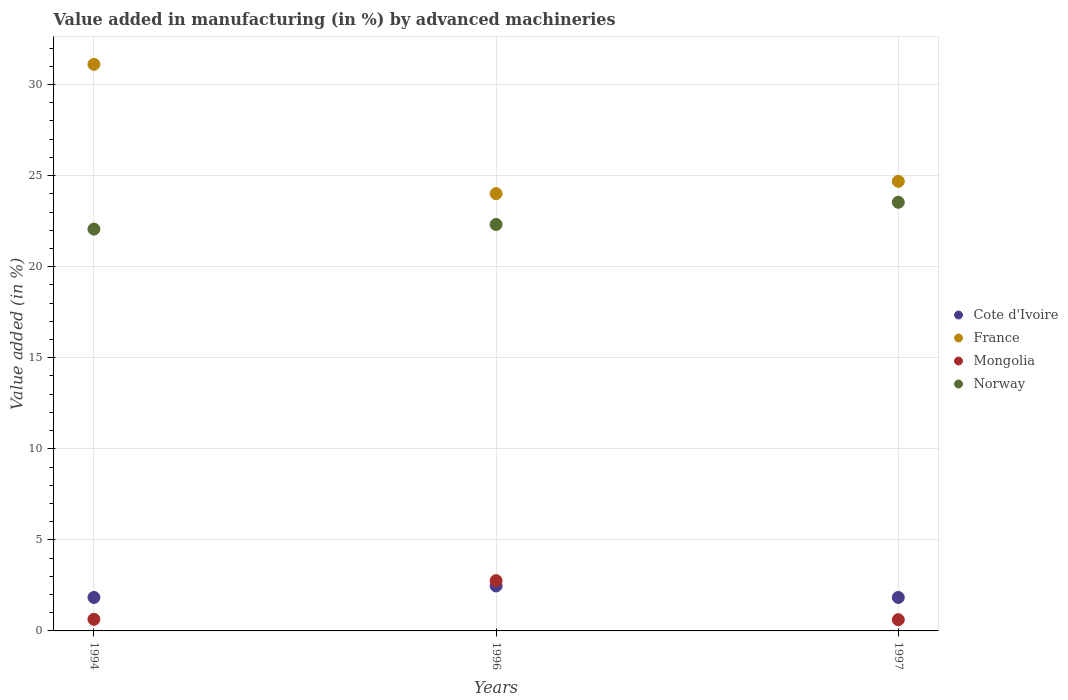What is the percentage of value added in manufacturing by advanced machineries in Mongolia in 1997?
Provide a succinct answer. 0.62. Across all years, what is the maximum percentage of value added in manufacturing by advanced machineries in Norway?
Ensure brevity in your answer.  23.54. Across all years, what is the minimum percentage of value added in manufacturing by advanced machineries in Norway?
Your answer should be compact. 22.06. What is the total percentage of value added in manufacturing by advanced machineries in France in the graph?
Give a very brief answer. 79.81. What is the difference between the percentage of value added in manufacturing by advanced machineries in Mongolia in 1996 and that in 1997?
Ensure brevity in your answer.  2.14. What is the difference between the percentage of value added in manufacturing by advanced machineries in France in 1997 and the percentage of value added in manufacturing by advanced machineries in Cote d'Ivoire in 1996?
Keep it short and to the point. 22.22. What is the average percentage of value added in manufacturing by advanced machineries in Mongolia per year?
Offer a very short reply. 1.34. In the year 1996, what is the difference between the percentage of value added in manufacturing by advanced machineries in Norway and percentage of value added in manufacturing by advanced machineries in France?
Ensure brevity in your answer.  -1.69. What is the ratio of the percentage of value added in manufacturing by advanced machineries in Mongolia in 1996 to that in 1997?
Your answer should be compact. 4.48. What is the difference between the highest and the second highest percentage of value added in manufacturing by advanced machineries in Norway?
Offer a very short reply. 1.22. What is the difference between the highest and the lowest percentage of value added in manufacturing by advanced machineries in Cote d'Ivoire?
Ensure brevity in your answer.  0.63. Is the sum of the percentage of value added in manufacturing by advanced machineries in Mongolia in 1996 and 1997 greater than the maximum percentage of value added in manufacturing by advanced machineries in Norway across all years?
Ensure brevity in your answer.  No. Is it the case that in every year, the sum of the percentage of value added in manufacturing by advanced machineries in Mongolia and percentage of value added in manufacturing by advanced machineries in Cote d'Ivoire  is greater than the sum of percentage of value added in manufacturing by advanced machineries in France and percentage of value added in manufacturing by advanced machineries in Norway?
Keep it short and to the point. No. Is it the case that in every year, the sum of the percentage of value added in manufacturing by advanced machineries in France and percentage of value added in manufacturing by advanced machineries in Cote d'Ivoire  is greater than the percentage of value added in manufacturing by advanced machineries in Norway?
Offer a very short reply. Yes. Is the percentage of value added in manufacturing by advanced machineries in Norway strictly greater than the percentage of value added in manufacturing by advanced machineries in Mongolia over the years?
Provide a succinct answer. Yes. Is the percentage of value added in manufacturing by advanced machineries in Cote d'Ivoire strictly less than the percentage of value added in manufacturing by advanced machineries in France over the years?
Give a very brief answer. Yes. Does the graph contain any zero values?
Keep it short and to the point. No. Does the graph contain grids?
Give a very brief answer. Yes. How many legend labels are there?
Your answer should be compact. 4. How are the legend labels stacked?
Ensure brevity in your answer.  Vertical. What is the title of the graph?
Offer a terse response. Value added in manufacturing (in %) by advanced machineries. What is the label or title of the X-axis?
Provide a succinct answer. Years. What is the label or title of the Y-axis?
Your response must be concise. Value added (in %). What is the Value added (in %) of Cote d'Ivoire in 1994?
Offer a terse response. 1.84. What is the Value added (in %) of France in 1994?
Make the answer very short. 31.11. What is the Value added (in %) of Mongolia in 1994?
Give a very brief answer. 0.64. What is the Value added (in %) of Norway in 1994?
Make the answer very short. 22.06. What is the Value added (in %) of Cote d'Ivoire in 1996?
Give a very brief answer. 2.47. What is the Value added (in %) in France in 1996?
Your answer should be very brief. 24.01. What is the Value added (in %) in Mongolia in 1996?
Your answer should be very brief. 2.76. What is the Value added (in %) in Norway in 1996?
Your answer should be compact. 22.32. What is the Value added (in %) in Cote d'Ivoire in 1997?
Offer a terse response. 1.84. What is the Value added (in %) of France in 1997?
Provide a succinct answer. 24.69. What is the Value added (in %) of Mongolia in 1997?
Provide a succinct answer. 0.62. What is the Value added (in %) in Norway in 1997?
Provide a succinct answer. 23.54. Across all years, what is the maximum Value added (in %) in Cote d'Ivoire?
Keep it short and to the point. 2.47. Across all years, what is the maximum Value added (in %) in France?
Your answer should be very brief. 31.11. Across all years, what is the maximum Value added (in %) of Mongolia?
Your answer should be compact. 2.76. Across all years, what is the maximum Value added (in %) in Norway?
Your answer should be very brief. 23.54. Across all years, what is the minimum Value added (in %) of Cote d'Ivoire?
Your answer should be very brief. 1.84. Across all years, what is the minimum Value added (in %) in France?
Your answer should be very brief. 24.01. Across all years, what is the minimum Value added (in %) in Mongolia?
Ensure brevity in your answer.  0.62. Across all years, what is the minimum Value added (in %) of Norway?
Offer a terse response. 22.06. What is the total Value added (in %) of Cote d'Ivoire in the graph?
Your answer should be compact. 6.14. What is the total Value added (in %) of France in the graph?
Make the answer very short. 79.81. What is the total Value added (in %) of Mongolia in the graph?
Ensure brevity in your answer.  4.01. What is the total Value added (in %) of Norway in the graph?
Give a very brief answer. 67.92. What is the difference between the Value added (in %) in Cote d'Ivoire in 1994 and that in 1996?
Ensure brevity in your answer.  -0.63. What is the difference between the Value added (in %) in France in 1994 and that in 1996?
Give a very brief answer. 7.1. What is the difference between the Value added (in %) of Mongolia in 1994 and that in 1996?
Provide a succinct answer. -2.12. What is the difference between the Value added (in %) of Norway in 1994 and that in 1996?
Give a very brief answer. -0.25. What is the difference between the Value added (in %) of Cote d'Ivoire in 1994 and that in 1997?
Offer a terse response. -0. What is the difference between the Value added (in %) in France in 1994 and that in 1997?
Offer a very short reply. 6.42. What is the difference between the Value added (in %) in Mongolia in 1994 and that in 1997?
Make the answer very short. 0.02. What is the difference between the Value added (in %) in Norway in 1994 and that in 1997?
Your response must be concise. -1.47. What is the difference between the Value added (in %) of Cote d'Ivoire in 1996 and that in 1997?
Your answer should be very brief. 0.63. What is the difference between the Value added (in %) of France in 1996 and that in 1997?
Provide a short and direct response. -0.68. What is the difference between the Value added (in %) of Mongolia in 1996 and that in 1997?
Offer a terse response. 2.14. What is the difference between the Value added (in %) of Norway in 1996 and that in 1997?
Give a very brief answer. -1.22. What is the difference between the Value added (in %) in Cote d'Ivoire in 1994 and the Value added (in %) in France in 1996?
Provide a succinct answer. -22.17. What is the difference between the Value added (in %) in Cote d'Ivoire in 1994 and the Value added (in %) in Mongolia in 1996?
Your answer should be very brief. -0.92. What is the difference between the Value added (in %) of Cote d'Ivoire in 1994 and the Value added (in %) of Norway in 1996?
Ensure brevity in your answer.  -20.48. What is the difference between the Value added (in %) of France in 1994 and the Value added (in %) of Mongolia in 1996?
Your answer should be compact. 28.35. What is the difference between the Value added (in %) in France in 1994 and the Value added (in %) in Norway in 1996?
Provide a short and direct response. 8.79. What is the difference between the Value added (in %) of Mongolia in 1994 and the Value added (in %) of Norway in 1996?
Make the answer very short. -21.68. What is the difference between the Value added (in %) of Cote d'Ivoire in 1994 and the Value added (in %) of France in 1997?
Offer a terse response. -22.85. What is the difference between the Value added (in %) in Cote d'Ivoire in 1994 and the Value added (in %) in Mongolia in 1997?
Offer a very short reply. 1.22. What is the difference between the Value added (in %) of Cote d'Ivoire in 1994 and the Value added (in %) of Norway in 1997?
Keep it short and to the point. -21.7. What is the difference between the Value added (in %) in France in 1994 and the Value added (in %) in Mongolia in 1997?
Ensure brevity in your answer.  30.49. What is the difference between the Value added (in %) in France in 1994 and the Value added (in %) in Norway in 1997?
Ensure brevity in your answer.  7.57. What is the difference between the Value added (in %) in Mongolia in 1994 and the Value added (in %) in Norway in 1997?
Your answer should be very brief. -22.9. What is the difference between the Value added (in %) in Cote d'Ivoire in 1996 and the Value added (in %) in France in 1997?
Offer a very short reply. -22.22. What is the difference between the Value added (in %) in Cote d'Ivoire in 1996 and the Value added (in %) in Mongolia in 1997?
Your response must be concise. 1.85. What is the difference between the Value added (in %) of Cote d'Ivoire in 1996 and the Value added (in %) of Norway in 1997?
Make the answer very short. -21.07. What is the difference between the Value added (in %) in France in 1996 and the Value added (in %) in Mongolia in 1997?
Give a very brief answer. 23.39. What is the difference between the Value added (in %) of France in 1996 and the Value added (in %) of Norway in 1997?
Keep it short and to the point. 0.47. What is the difference between the Value added (in %) in Mongolia in 1996 and the Value added (in %) in Norway in 1997?
Your answer should be compact. -20.78. What is the average Value added (in %) in Cote d'Ivoire per year?
Give a very brief answer. 2.05. What is the average Value added (in %) in France per year?
Your response must be concise. 26.6. What is the average Value added (in %) of Mongolia per year?
Your answer should be very brief. 1.34. What is the average Value added (in %) of Norway per year?
Your answer should be very brief. 22.64. In the year 1994, what is the difference between the Value added (in %) in Cote d'Ivoire and Value added (in %) in France?
Ensure brevity in your answer.  -29.27. In the year 1994, what is the difference between the Value added (in %) of Cote d'Ivoire and Value added (in %) of Mongolia?
Provide a short and direct response. 1.2. In the year 1994, what is the difference between the Value added (in %) of Cote d'Ivoire and Value added (in %) of Norway?
Offer a very short reply. -20.23. In the year 1994, what is the difference between the Value added (in %) of France and Value added (in %) of Mongolia?
Give a very brief answer. 30.47. In the year 1994, what is the difference between the Value added (in %) in France and Value added (in %) in Norway?
Offer a very short reply. 9.05. In the year 1994, what is the difference between the Value added (in %) in Mongolia and Value added (in %) in Norway?
Ensure brevity in your answer.  -21.43. In the year 1996, what is the difference between the Value added (in %) in Cote d'Ivoire and Value added (in %) in France?
Keep it short and to the point. -21.54. In the year 1996, what is the difference between the Value added (in %) of Cote d'Ivoire and Value added (in %) of Mongolia?
Keep it short and to the point. -0.29. In the year 1996, what is the difference between the Value added (in %) of Cote d'Ivoire and Value added (in %) of Norway?
Your response must be concise. -19.85. In the year 1996, what is the difference between the Value added (in %) in France and Value added (in %) in Mongolia?
Provide a short and direct response. 21.25. In the year 1996, what is the difference between the Value added (in %) of France and Value added (in %) of Norway?
Provide a short and direct response. 1.69. In the year 1996, what is the difference between the Value added (in %) in Mongolia and Value added (in %) in Norway?
Your response must be concise. -19.56. In the year 1997, what is the difference between the Value added (in %) in Cote d'Ivoire and Value added (in %) in France?
Your response must be concise. -22.85. In the year 1997, what is the difference between the Value added (in %) in Cote d'Ivoire and Value added (in %) in Mongolia?
Your answer should be very brief. 1.22. In the year 1997, what is the difference between the Value added (in %) of Cote d'Ivoire and Value added (in %) of Norway?
Your answer should be very brief. -21.7. In the year 1997, what is the difference between the Value added (in %) of France and Value added (in %) of Mongolia?
Make the answer very short. 24.07. In the year 1997, what is the difference between the Value added (in %) in France and Value added (in %) in Norway?
Ensure brevity in your answer.  1.15. In the year 1997, what is the difference between the Value added (in %) in Mongolia and Value added (in %) in Norway?
Provide a succinct answer. -22.92. What is the ratio of the Value added (in %) in Cote d'Ivoire in 1994 to that in 1996?
Keep it short and to the point. 0.74. What is the ratio of the Value added (in %) of France in 1994 to that in 1996?
Provide a succinct answer. 1.3. What is the ratio of the Value added (in %) of Mongolia in 1994 to that in 1996?
Give a very brief answer. 0.23. What is the ratio of the Value added (in %) of Norway in 1994 to that in 1996?
Provide a short and direct response. 0.99. What is the ratio of the Value added (in %) in Cote d'Ivoire in 1994 to that in 1997?
Your response must be concise. 1. What is the ratio of the Value added (in %) in France in 1994 to that in 1997?
Your answer should be very brief. 1.26. What is the ratio of the Value added (in %) of Mongolia in 1994 to that in 1997?
Give a very brief answer. 1.03. What is the ratio of the Value added (in %) in Norway in 1994 to that in 1997?
Offer a terse response. 0.94. What is the ratio of the Value added (in %) of Cote d'Ivoire in 1996 to that in 1997?
Offer a very short reply. 1.34. What is the ratio of the Value added (in %) in France in 1996 to that in 1997?
Provide a short and direct response. 0.97. What is the ratio of the Value added (in %) of Mongolia in 1996 to that in 1997?
Ensure brevity in your answer.  4.48. What is the ratio of the Value added (in %) in Norway in 1996 to that in 1997?
Keep it short and to the point. 0.95. What is the difference between the highest and the second highest Value added (in %) in Cote d'Ivoire?
Your answer should be compact. 0.63. What is the difference between the highest and the second highest Value added (in %) in France?
Your response must be concise. 6.42. What is the difference between the highest and the second highest Value added (in %) in Mongolia?
Provide a short and direct response. 2.12. What is the difference between the highest and the second highest Value added (in %) in Norway?
Make the answer very short. 1.22. What is the difference between the highest and the lowest Value added (in %) in Cote d'Ivoire?
Keep it short and to the point. 0.63. What is the difference between the highest and the lowest Value added (in %) in France?
Provide a short and direct response. 7.1. What is the difference between the highest and the lowest Value added (in %) of Mongolia?
Give a very brief answer. 2.14. What is the difference between the highest and the lowest Value added (in %) of Norway?
Offer a terse response. 1.47. 